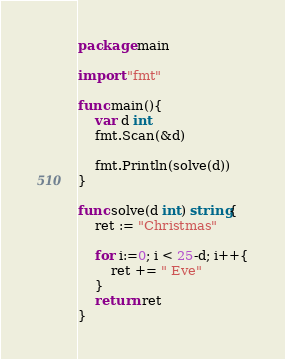Convert code to text. <code><loc_0><loc_0><loc_500><loc_500><_Go_>package main

import "fmt"

func main(){
	var d int
	fmt.Scan(&d)

	fmt.Println(solve(d))
}

func solve(d int) string{
	ret := "Christmas"

	for i:=0; i < 25-d; i++{
		ret += " Eve"
	}
	return ret
}</code> 